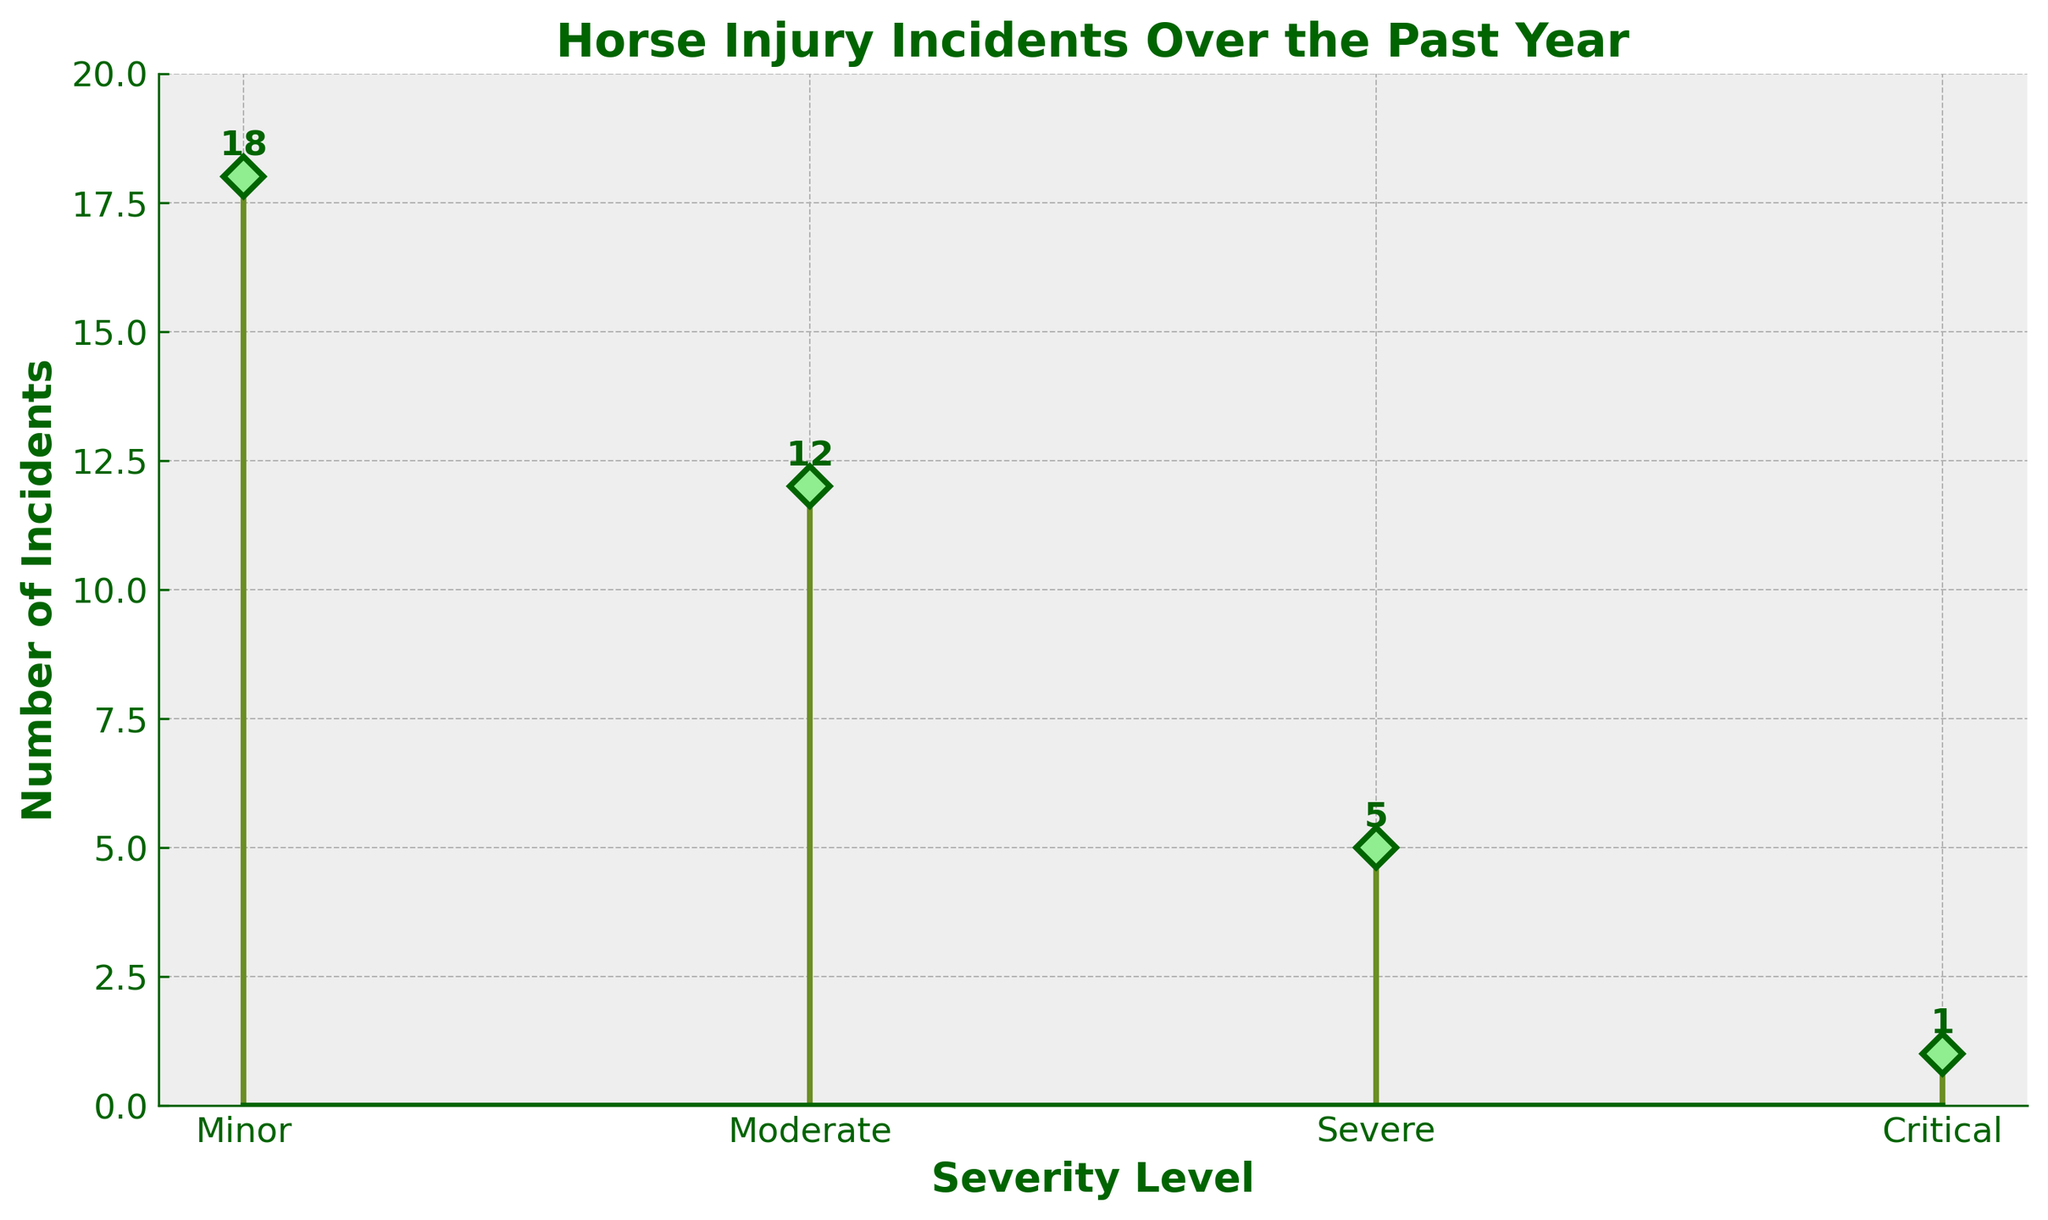What's the title of the figure? The title of the figure is typically placed at the top of the chart. This figure's title can be read from that position.
Answer: Horse Injury Incidents Over the Past Year How many severity levels are represented in the figure? The severity levels can be identified from the x-axis labels of the stem plot. There are four labels: Minor, Moderate, Severe, and Critical.
Answer: 4 Which severity level had the highest number of incidents? By examining the height of the stems and the annotations near the markers, it's clear that the severity level with the highest count is the tallest bar, labeled as Minor.
Answer: Minor What is the total number of incidents reported? To find the total number of incidents, sum the counts for all severity levels: 18 (Minor) + 12 (Moderate) + 5 (Severe) + 1 (Critical). This calculation yields a total.
Answer: 36 By how much does the number of Minor incidents exceed the number of Severe incidents? To determine the difference, subtract the count of Severe incidents (5) from the count of Minor incidents (18).
Answer: 13 What is the average number of incidents per severity level? Calculate the average by dividing the total number of incidents (36) by the number of severity levels (4). The result of this division is the average.
Answer: 9 How does the number of Moderate incidents compare to the number of Critical incidents? Compare the two values directly: Moderate has 12 incidents, while Critical has only 1. So, the number of Moderate incidents is greater.
Answer: Moderate is greater Is there any severity level with fewer than 5 incidents? By checking the counts at each severity level, we can see that the Critical level has 1 incident, which is less than 5.
Answer: Yes, Critical What can you say about the trend in incident severity in terms of their counts? Observing the heights of the stems from left to right (Minor to Critical), it is evident that as severity increases, the number of incidents generally decreases.
Answer: Incidents decrease with increasing severity Given this distribution, which severity levels might the company prioritize for safety measures, and why? Since Minor and Moderate incidents occur most frequently (18 and 12 respectively), prioritizing these levels may help in reducing the overall number of incidents most effectively.
Answer: Prioritize Minor and Moderate 